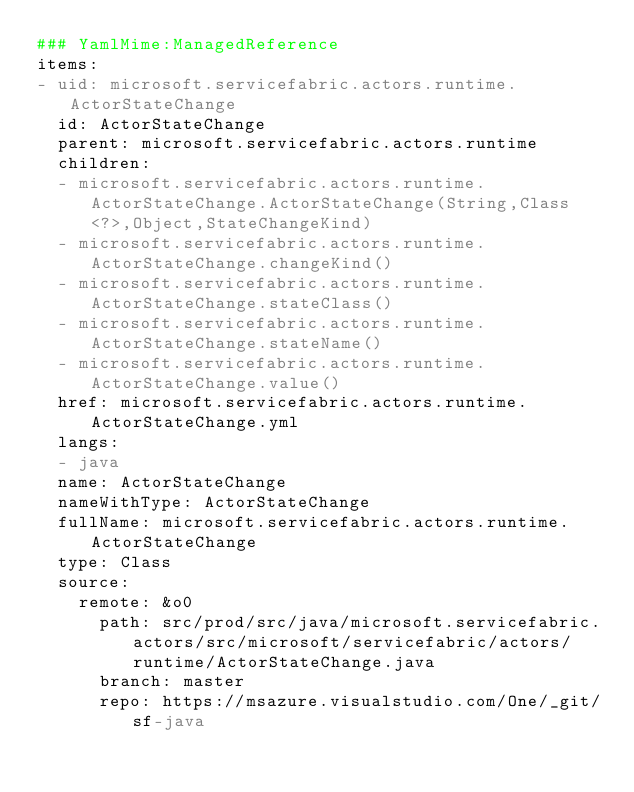Convert code to text. <code><loc_0><loc_0><loc_500><loc_500><_YAML_>### YamlMime:ManagedReference
items:
- uid: microsoft.servicefabric.actors.runtime.ActorStateChange
  id: ActorStateChange
  parent: microsoft.servicefabric.actors.runtime
  children:
  - microsoft.servicefabric.actors.runtime.ActorStateChange.ActorStateChange(String,Class<?>,Object,StateChangeKind)
  - microsoft.servicefabric.actors.runtime.ActorStateChange.changeKind()
  - microsoft.servicefabric.actors.runtime.ActorStateChange.stateClass()
  - microsoft.servicefabric.actors.runtime.ActorStateChange.stateName()
  - microsoft.servicefabric.actors.runtime.ActorStateChange.value()
  href: microsoft.servicefabric.actors.runtime.ActorStateChange.yml
  langs:
  - java
  name: ActorStateChange
  nameWithType: ActorStateChange
  fullName: microsoft.servicefabric.actors.runtime.ActorStateChange
  type: Class
  source:
    remote: &o0
      path: src/prod/src/java/microsoft.servicefabric.actors/src/microsoft/servicefabric/actors/runtime/ActorStateChange.java
      branch: master
      repo: https://msazure.visualstudio.com/One/_git/sf-java</code> 